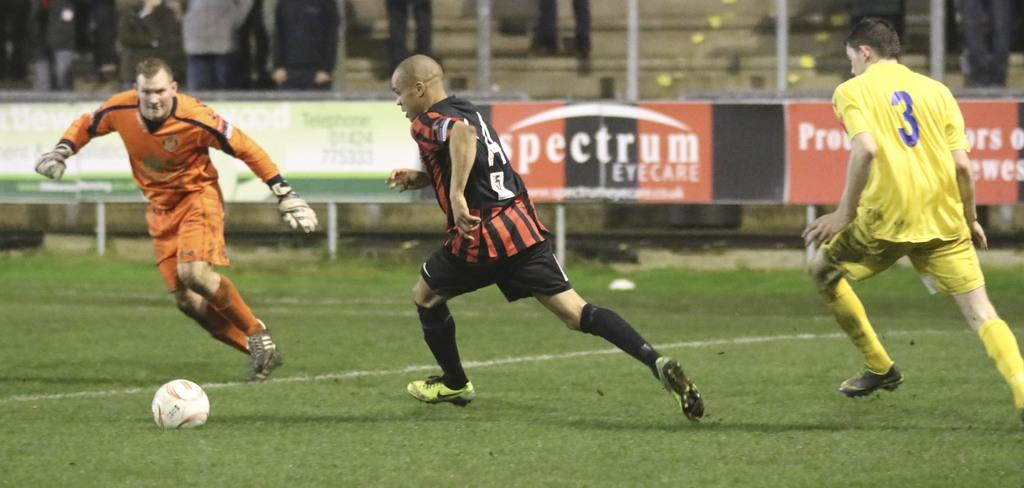<image>
Describe the image concisely. some soccer players, one with the number 3 on 